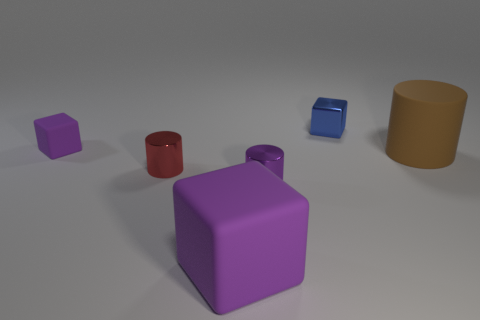Subtract all purple cubes. How many cubes are left? 1 Subtract all yellow balls. How many purple blocks are left? 2 Subtract 2 blocks. How many blocks are left? 1 Add 1 blue blocks. How many objects exist? 7 Subtract all purple cylinders. Subtract all yellow balls. How many cylinders are left? 2 Subtract all small red cylinders. Subtract all tiny purple metallic cylinders. How many objects are left? 4 Add 4 big blocks. How many big blocks are left? 5 Add 5 rubber cylinders. How many rubber cylinders exist? 6 Subtract 0 green cubes. How many objects are left? 6 